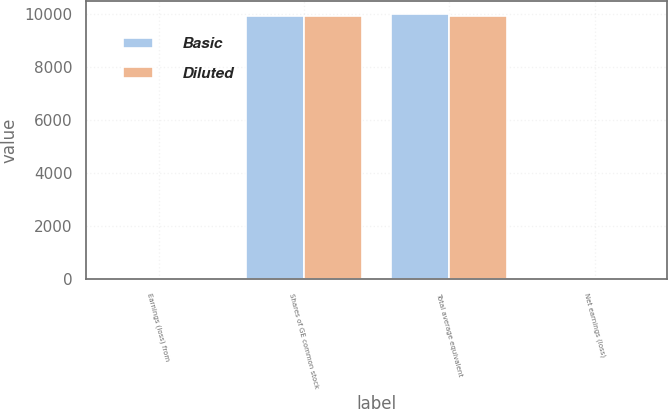Convert chart. <chart><loc_0><loc_0><loc_500><loc_500><stacked_bar_chart><ecel><fcel>Earnings (loss) from<fcel>Shares of GE common stock<fcel>Total average equivalent<fcel>Net earnings (loss)<nl><fcel>Basic<fcel>0.78<fcel>9944<fcel>10016<fcel>0.61<nl><fcel>Diluted<fcel>0.78<fcel>9944<fcel>9944<fcel>0.62<nl></chart> 